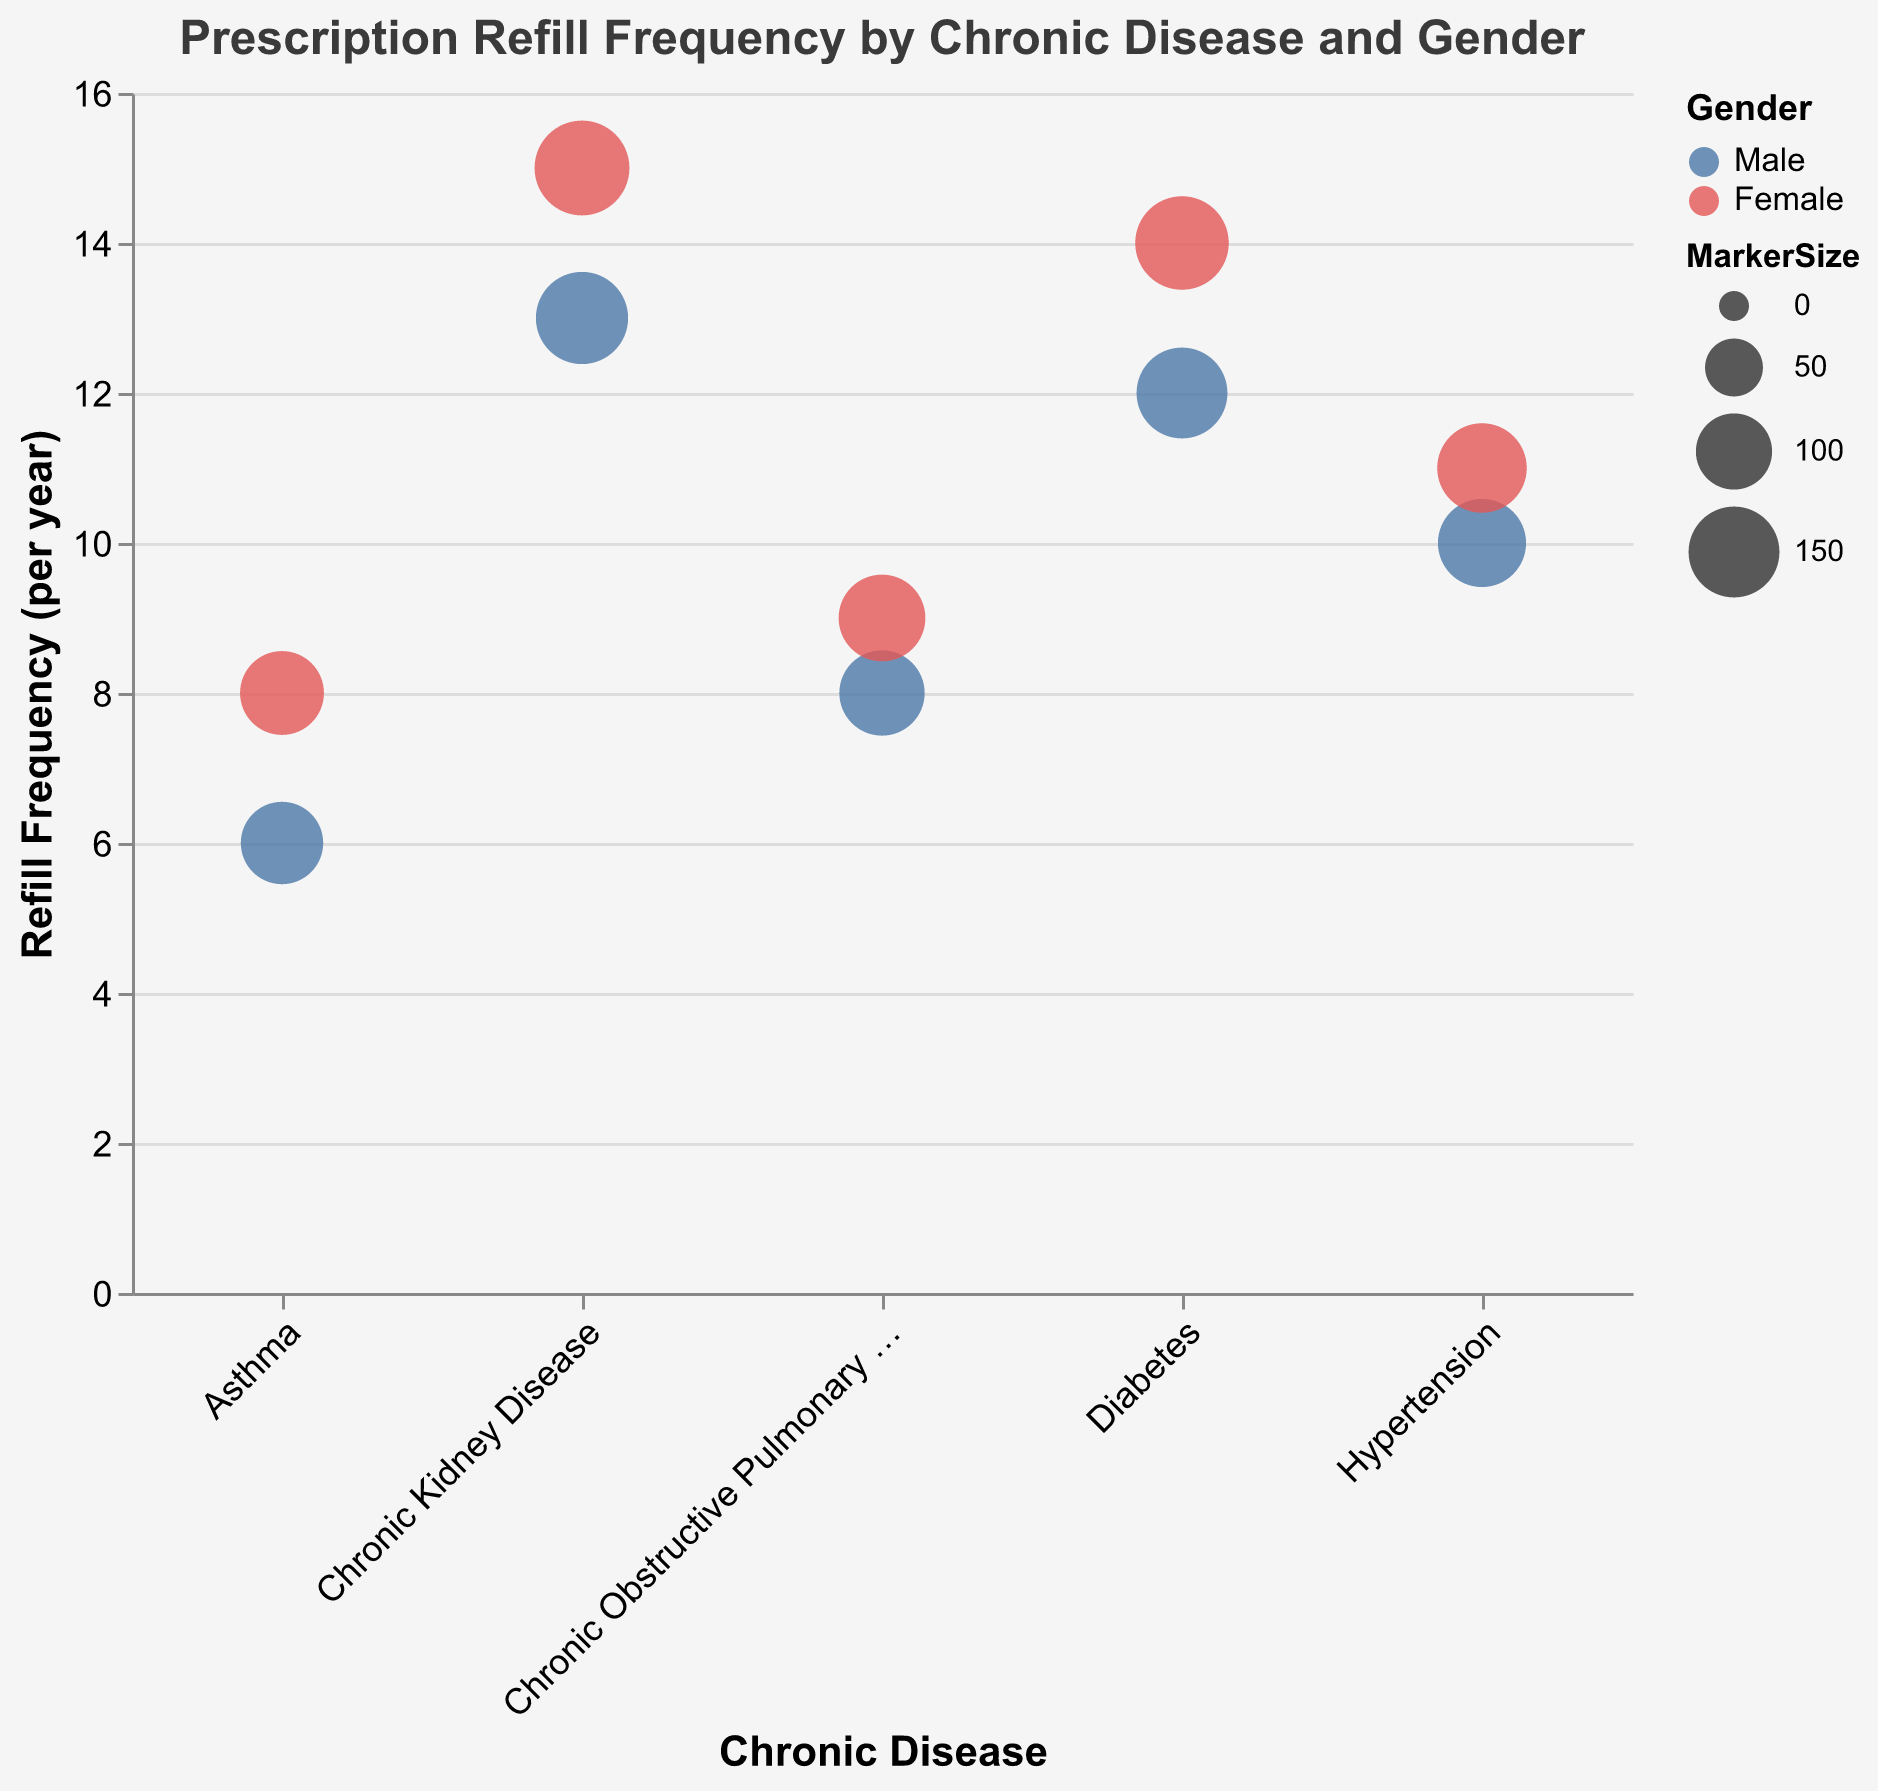What is the title of the chart? The title of the chart is shown at the top in larger and bold font compared to the other text elements. This is extracted directly from that position.
Answer: Prescription Refill Frequency by Chronic Disease and Gender Which disease has the highest refill frequency for female patients? To determine the highest refill frequency for female patients, we look at the y-axis values for the female markers (displayed in red) and find the highest value among them. The highest frequency is for Chronic Kidney Disease at 15.
Answer: Chronic Kidney Disease How many chronic diseases are represented in the chart? To find the number of chronic diseases, count the distinct categories on the x-axis labeled under "Chronic Disease."
Answer: 5 Which gender has a higher refill frequency for Asthma? By comparing the y-values for both male and female markers under Asthma, we see that the female marker (in red) is higher than the male marker (in blue).
Answer: Female What is the average refill frequency for Hypertension across both genders? Add the refill frequencies for males and females with Hypertension and divide by 2: (10 + 11) / 2.
Answer: 10.5 Compare the refill frequency between male and female patients with Diabetes. For Diabetes, the refill frequency for males is 12 and for females is 14. Hence, females have a higher refill frequency by 2 refills per year.
Answer: Females have 2 more refills per year What is the color used to represent male patients? The legend indicates that the color used for male patients is displayed as the blue hue on the bubbles.
Answer: Blue Rank the diseases by refill frequency for male patients, starting with the highest. Compare the y-axis values for all male patients across the diseases: Chronic Kidney Disease (13), Diabetes (12), Hypertension (10), COPD (8), Asthma (6).
Answer: Chronic Kidney Disease, Diabetes, Hypertension, COPD, Asthma Which chronic disease has the lowest refill frequency regardless of gender? The lowest refill frequency found on the y-axis, irrespective of gender, is Asthma with male at 6 and female at 8.
Answer: Asthma Is there any disease where both genders have an equal refill frequency? Look for a disease where the refill frequency values on the y-axis for both male and female markers are the same. In this case, no diseases have equal refill frequencies for both genders.
Answer: No 